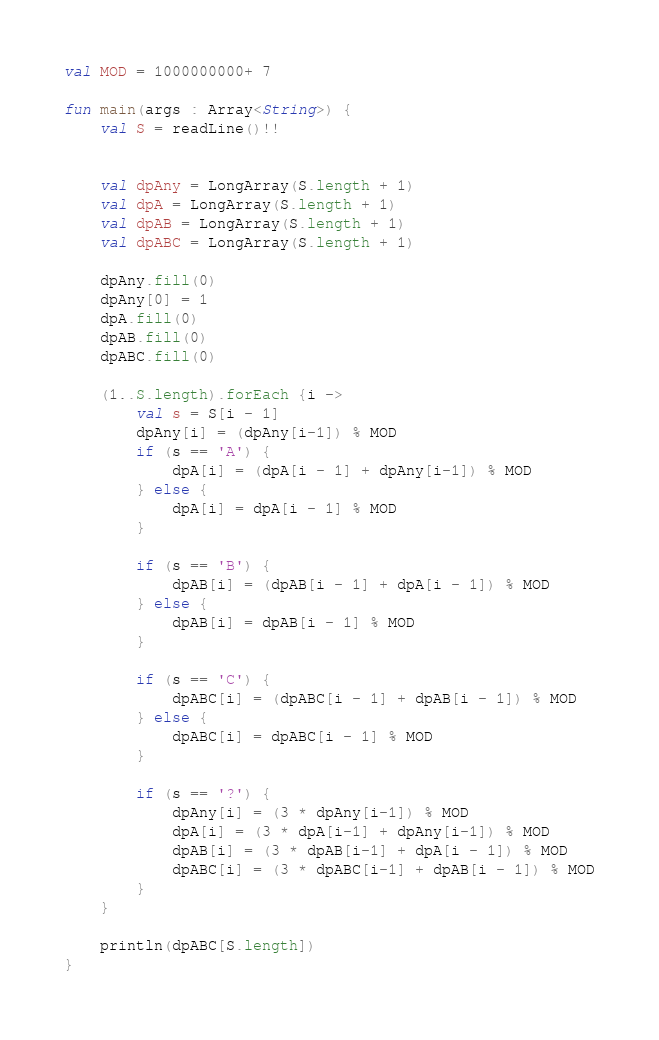<code> <loc_0><loc_0><loc_500><loc_500><_Kotlin_>val MOD = 1000000000+ 7

fun main(args : Array<String>) {
    val S = readLine()!!


    val dpAny = LongArray(S.length + 1)
    val dpA = LongArray(S.length + 1)
    val dpAB = LongArray(S.length + 1)
    val dpABC = LongArray(S.length + 1)

    dpAny.fill(0)
    dpAny[0] = 1
    dpA.fill(0)
    dpAB.fill(0)
    dpABC.fill(0)

    (1..S.length).forEach {i ->
        val s = S[i - 1]
        dpAny[i] = (dpAny[i-1]) % MOD
        if (s == 'A') {
            dpA[i] = (dpA[i - 1] + dpAny[i-1]) % MOD
        } else {
            dpA[i] = dpA[i - 1] % MOD
        }

        if (s == 'B') {
            dpAB[i] = (dpAB[i - 1] + dpA[i - 1]) % MOD
        } else {
            dpAB[i] = dpAB[i - 1] % MOD
        }

        if (s == 'C') {
            dpABC[i] = (dpABC[i - 1] + dpAB[i - 1]) % MOD
        } else {
            dpABC[i] = dpABC[i - 1] % MOD
        }

        if (s == '?') {
            dpAny[i] = (3 * dpAny[i-1]) % MOD
            dpA[i] = (3 * dpA[i-1] + dpAny[i-1]) % MOD
            dpAB[i] = (3 * dpAB[i-1] + dpA[i - 1]) % MOD
            dpABC[i] = (3 * dpABC[i-1] + dpAB[i - 1]) % MOD
        }
    }

    println(dpABC[S.length])
}</code> 